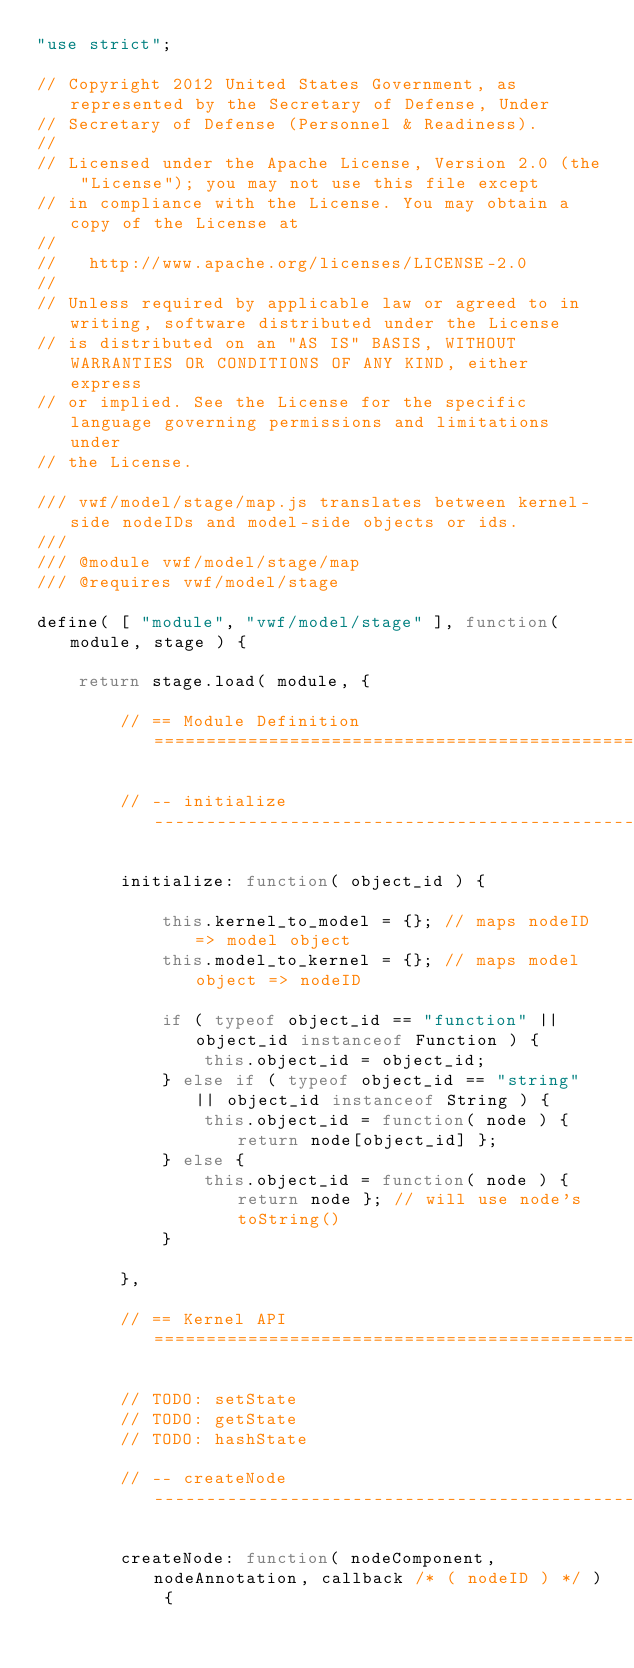Convert code to text. <code><loc_0><loc_0><loc_500><loc_500><_JavaScript_>"use strict";

// Copyright 2012 United States Government, as represented by the Secretary of Defense, Under
// Secretary of Defense (Personnel & Readiness).
// 
// Licensed under the Apache License, Version 2.0 (the "License"); you may not use this file except
// in compliance with the License. You may obtain a copy of the License at
// 
//   http://www.apache.org/licenses/LICENSE-2.0
// 
// Unless required by applicable law or agreed to in writing, software distributed under the License
// is distributed on an "AS IS" BASIS, WITHOUT WARRANTIES OR CONDITIONS OF ANY KIND, either express
// or implied. See the License for the specific language governing permissions and limitations under
// the License.

/// vwf/model/stage/map.js translates between kernel-side nodeIDs and model-side objects or ids.
/// 
/// @module vwf/model/stage/map
/// @requires vwf/model/stage

define( [ "module", "vwf/model/stage" ], function( module, stage ) {

    return stage.load( module, {

        // == Module Definition ====================================================================

        // -- initialize ---------------------------------------------------------------------------

        initialize: function( object_id ) {

            this.kernel_to_model = {}; // maps nodeID => model object
            this.model_to_kernel = {}; // maps model object => nodeID

            if ( typeof object_id == "function" || object_id instanceof Function ) {
                this.object_id = object_id;
            } else if ( typeof object_id == "string" || object_id instanceof String ) {
                this.object_id = function( node ) { return node[object_id] };
            } else {
                this.object_id = function( node ) { return node }; // will use node's toString()
            }

        },

        // == Kernel API ===========================================================================

        // TODO: setState
        // TODO: getState
        // TODO: hashState

        // -- createNode ---------------------------------------------------------------------------

        createNode: function( nodeComponent, nodeAnnotation, callback /* ( nodeID ) */ ) {</code> 